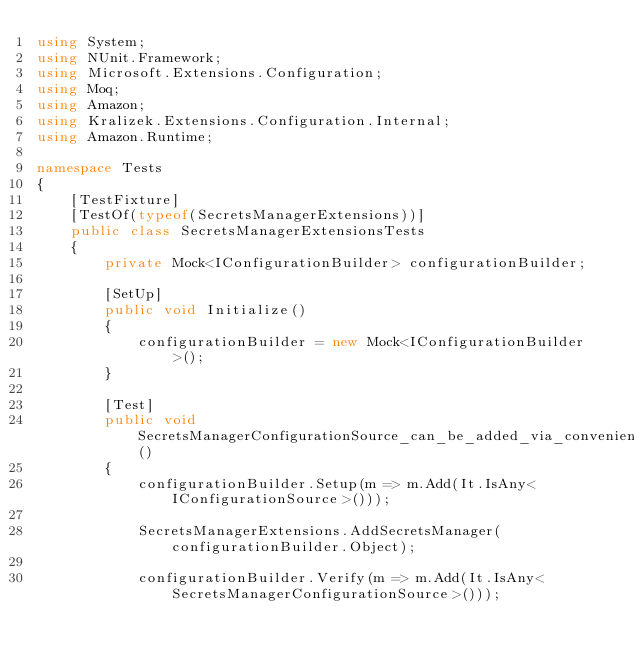<code> <loc_0><loc_0><loc_500><loc_500><_C#_>using System;
using NUnit.Framework;
using Microsoft.Extensions.Configuration;
using Moq;
using Amazon;
using Kralizek.Extensions.Configuration.Internal;
using Amazon.Runtime;

namespace Tests
{
    [TestFixture]
    [TestOf(typeof(SecretsManagerExtensions))]
    public class SecretsManagerExtensionsTests
    {
        private Mock<IConfigurationBuilder> configurationBuilder;

        [SetUp]
        public void Initialize()
        {
            configurationBuilder = new Mock<IConfigurationBuilder>();
        }

        [Test]
        public void SecretsManagerConfigurationSource_can_be_added_via_convenience_method_with_no_parameters()
        {
            configurationBuilder.Setup(m => m.Add(It.IsAny<IConfigurationSource>()));

            SecretsManagerExtensions.AddSecretsManager(configurationBuilder.Object);

            configurationBuilder.Verify(m => m.Add(It.IsAny<SecretsManagerConfigurationSource>()));</code> 